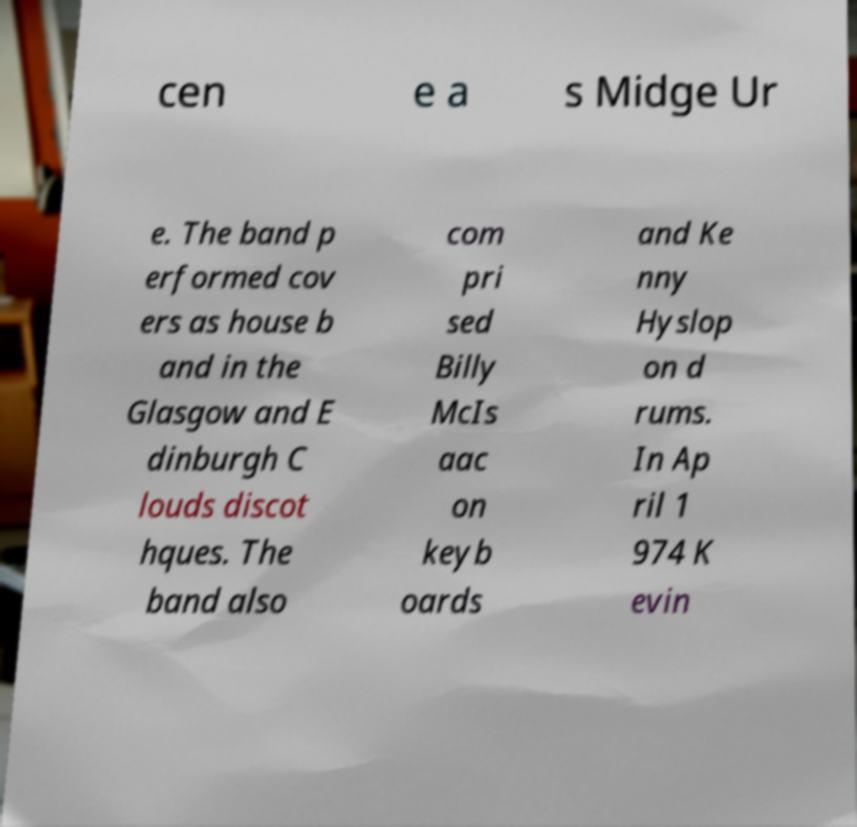Can you read and provide the text displayed in the image?This photo seems to have some interesting text. Can you extract and type it out for me? cen e a s Midge Ur e. The band p erformed cov ers as house b and in the Glasgow and E dinburgh C louds discot hques. The band also com pri sed Billy McIs aac on keyb oards and Ke nny Hyslop on d rums. In Ap ril 1 974 K evin 